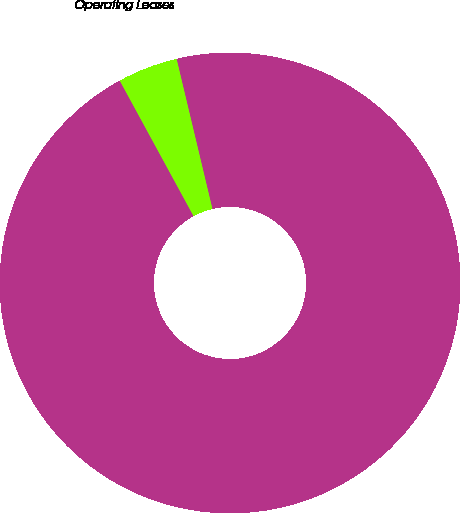<chart> <loc_0><loc_0><loc_500><loc_500><pie_chart><fcel>Capital Leases<fcel>Operating Leases<nl><fcel>95.79%<fcel>4.21%<nl></chart> 